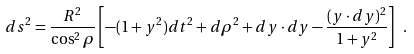Convert formula to latex. <formula><loc_0><loc_0><loc_500><loc_500>d s ^ { 2 } = \frac { R ^ { 2 } } { \cos ^ { 2 } \rho } \left [ - ( 1 + y ^ { 2 } ) d t ^ { 2 } + d \rho ^ { 2 } + d { y } \cdot d { y } - \frac { ( { y } \cdot d { y } ) ^ { 2 } } { 1 + y ^ { 2 } } \right ] \ .</formula> 